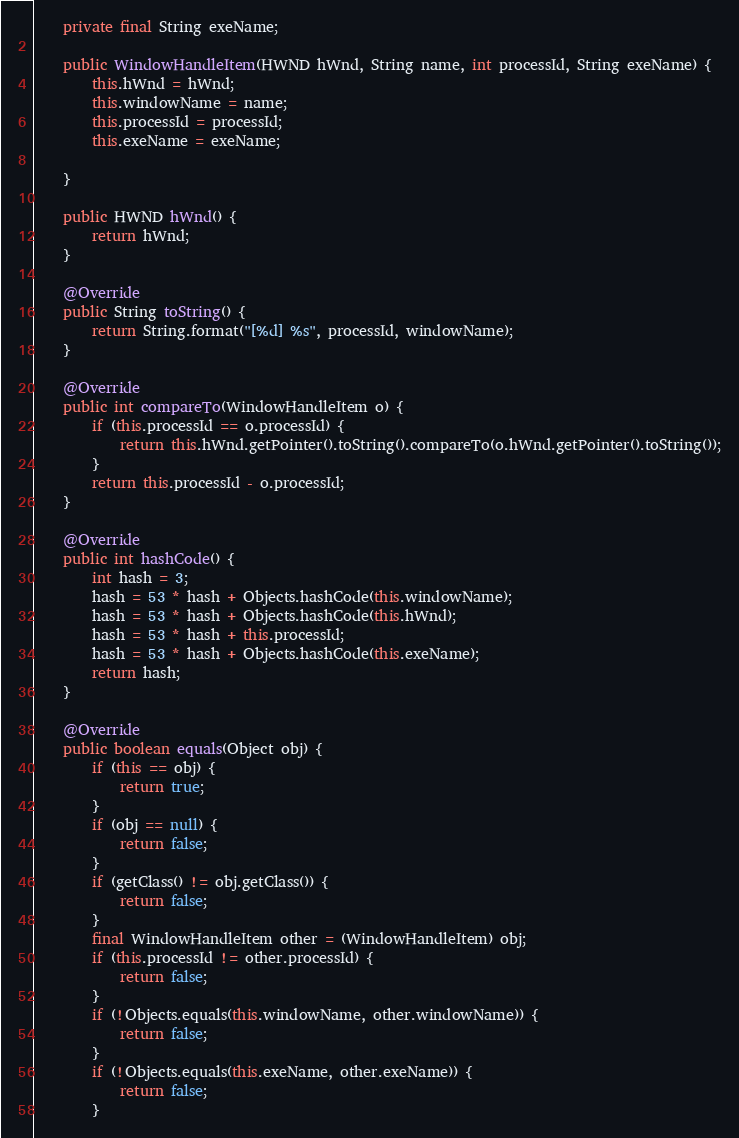Convert code to text. <code><loc_0><loc_0><loc_500><loc_500><_Java_>    private final String exeName;

    public WindowHandleItem(HWND hWnd, String name, int processId, String exeName) {
        this.hWnd = hWnd;
        this.windowName = name;
        this.processId = processId;
        this.exeName = exeName;

    }

    public HWND hWnd() {
        return hWnd;
    }

    @Override
    public String toString() {
        return String.format("[%d] %s", processId, windowName);
    }

    @Override
    public int compareTo(WindowHandleItem o) {
        if (this.processId == o.processId) {
            return this.hWnd.getPointer().toString().compareTo(o.hWnd.getPointer().toString());
        }
        return this.processId - o.processId;
    }

    @Override
    public int hashCode() {
        int hash = 3;
        hash = 53 * hash + Objects.hashCode(this.windowName);
        hash = 53 * hash + Objects.hashCode(this.hWnd);
        hash = 53 * hash + this.processId;
        hash = 53 * hash + Objects.hashCode(this.exeName);
        return hash;
    }

    @Override
    public boolean equals(Object obj) {
        if (this == obj) {
            return true;
        }
        if (obj == null) {
            return false;
        }
        if (getClass() != obj.getClass()) {
            return false;
        }
        final WindowHandleItem other = (WindowHandleItem) obj;
        if (this.processId != other.processId) {
            return false;
        }
        if (!Objects.equals(this.windowName, other.windowName)) {
            return false;
        }
        if (!Objects.equals(this.exeName, other.exeName)) {
            return false;
        }</code> 